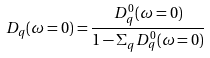<formula> <loc_0><loc_0><loc_500><loc_500>D _ { q } ( \omega = 0 ) = \frac { D ^ { 0 } _ { q } ( \omega = 0 ) } { 1 - \Sigma _ { q } D ^ { 0 } _ { q } ( \omega = 0 ) }</formula> 